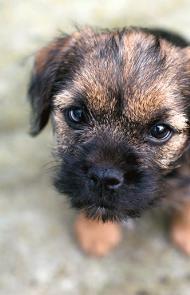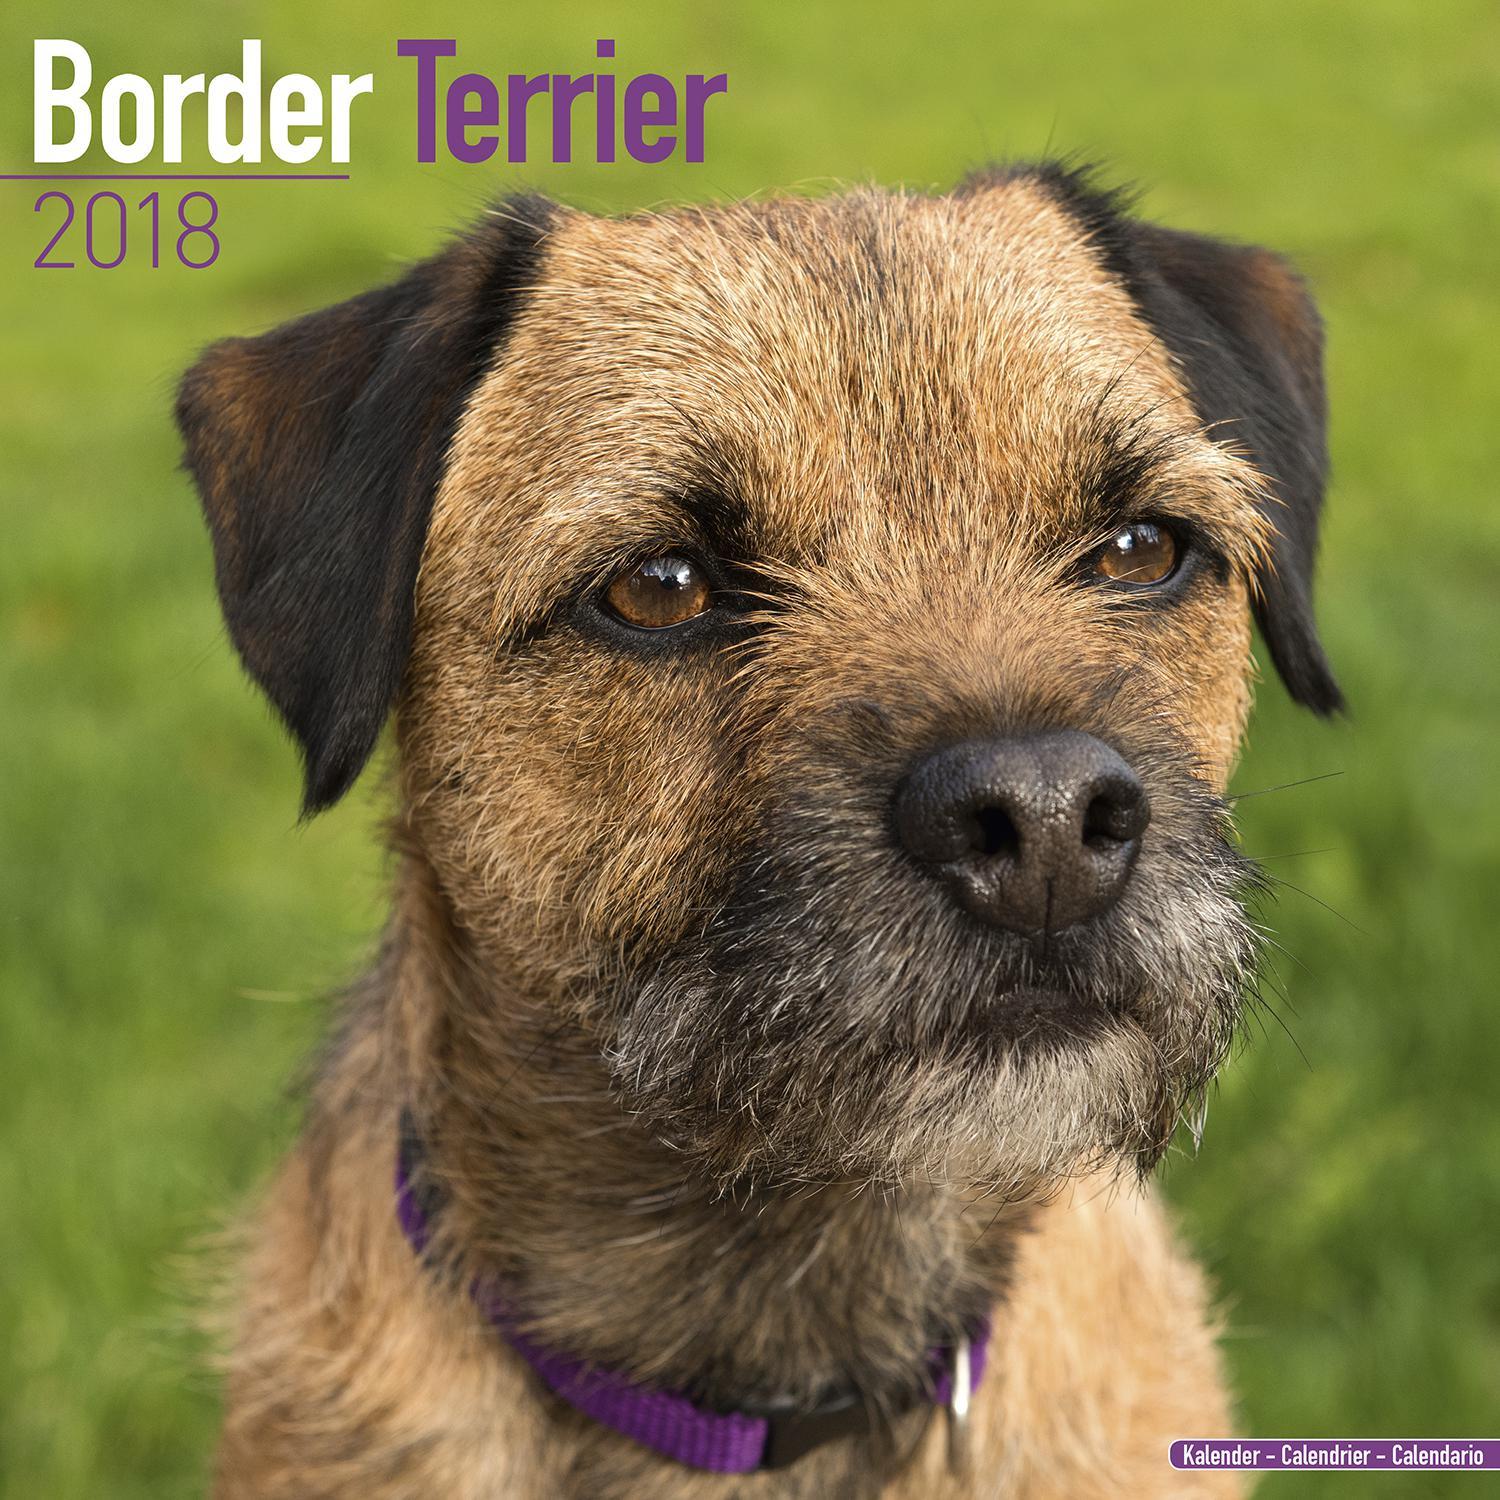The first image is the image on the left, the second image is the image on the right. For the images displayed, is the sentence "The left and right image contains the same number of dogs with at least one in the grass." factually correct? Answer yes or no. Yes. The first image is the image on the left, the second image is the image on the right. Given the left and right images, does the statement "One image includes a dog that is sitting upright, and the other image contains a single dog which is standing up." hold true? Answer yes or no. No. 